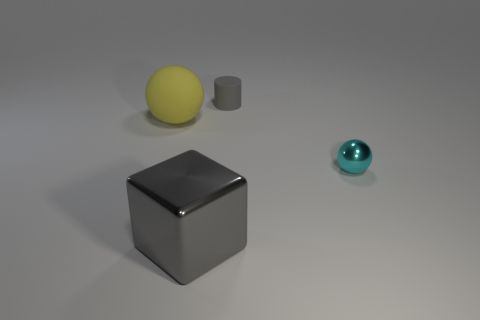There is a rubber cylinder that is the same color as the large metallic cube; what is its size?
Keep it short and to the point. Small. What number of things are the same color as the tiny cylinder?
Your answer should be compact. 1. There is a tiny matte thing that is the same color as the big shiny block; what shape is it?
Keep it short and to the point. Cylinder. Is the color of the small cylinder the same as the shiny block?
Ensure brevity in your answer.  Yes. The rubber ball is what color?
Ensure brevity in your answer.  Yellow. What number of other objects are there of the same material as the cyan sphere?
Offer a very short reply. 1. What number of gray things are either cubes or spheres?
Provide a short and direct response. 1. There is a metal object right of the large gray block; is it the same shape as the rubber object on the left side of the cylinder?
Provide a succinct answer. Yes. Is the color of the big shiny object the same as the matte thing that is right of the big metal thing?
Your response must be concise. Yes. There is a small thing that is behind the cyan sphere; is it the same color as the rubber ball?
Keep it short and to the point. No. 